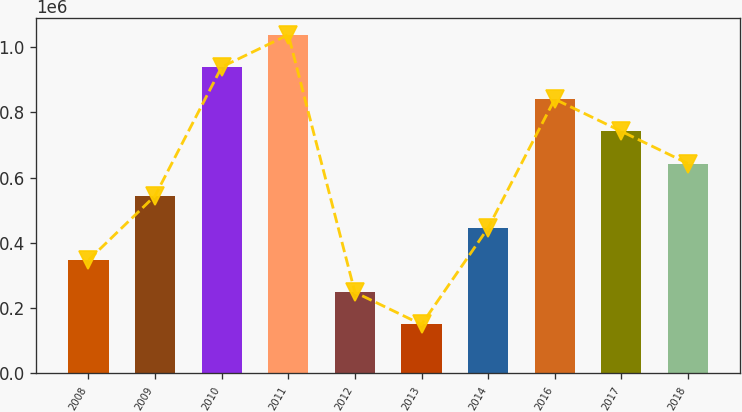<chart> <loc_0><loc_0><loc_500><loc_500><bar_chart><fcel>2008<fcel>2009<fcel>2010<fcel>2011<fcel>2012<fcel>2013<fcel>2014<fcel>2016<fcel>2017<fcel>2018<nl><fcel>347241<fcel>544482<fcel>938965<fcel>1.03759e+06<fcel>248621<fcel>150000<fcel>445862<fcel>840344<fcel>741724<fcel>643103<nl></chart> 